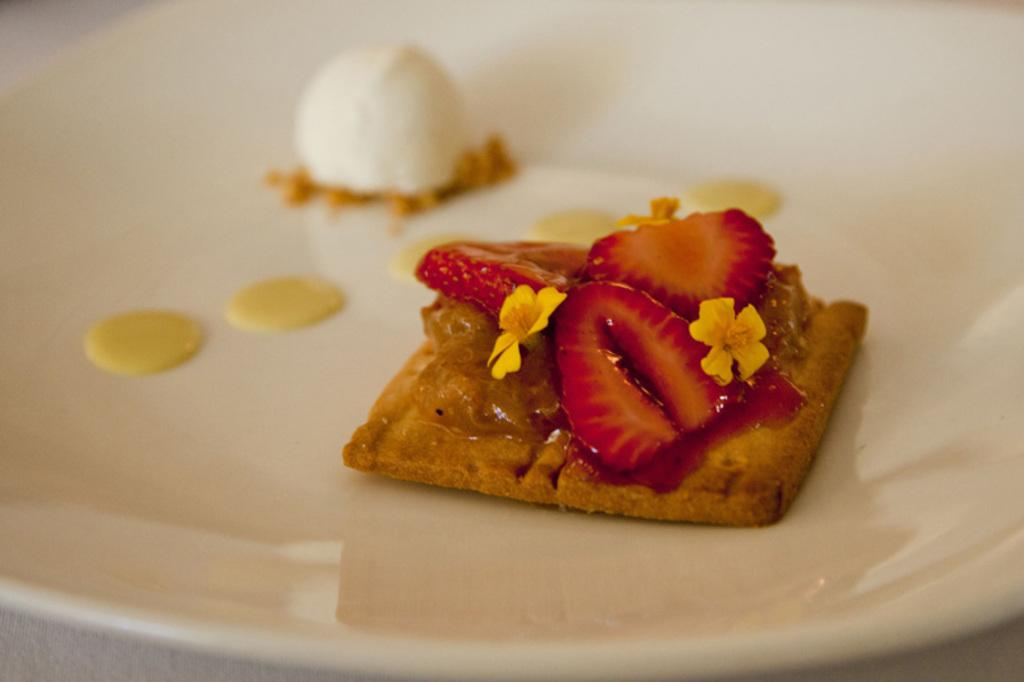What object can be seen in the image that is typically used for serving food? There is a plate in the image that is typically used for serving food. What is on the plate in the image? There is food on the plate in the image. How many brothers are sitting at the table with the plate in the image? There is no information about brothers in the image. 